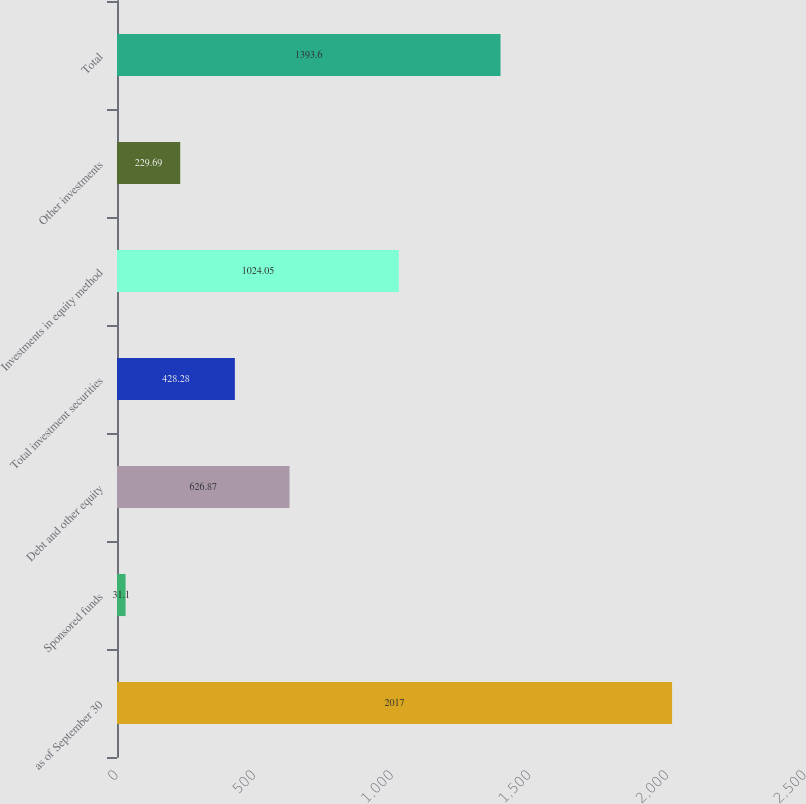<chart> <loc_0><loc_0><loc_500><loc_500><bar_chart><fcel>as of September 30<fcel>Sponsored funds<fcel>Debt and other equity<fcel>Total investment securities<fcel>Investments in equity method<fcel>Other investments<fcel>Total<nl><fcel>2017<fcel>31.1<fcel>626.87<fcel>428.28<fcel>1024.05<fcel>229.69<fcel>1393.6<nl></chart> 